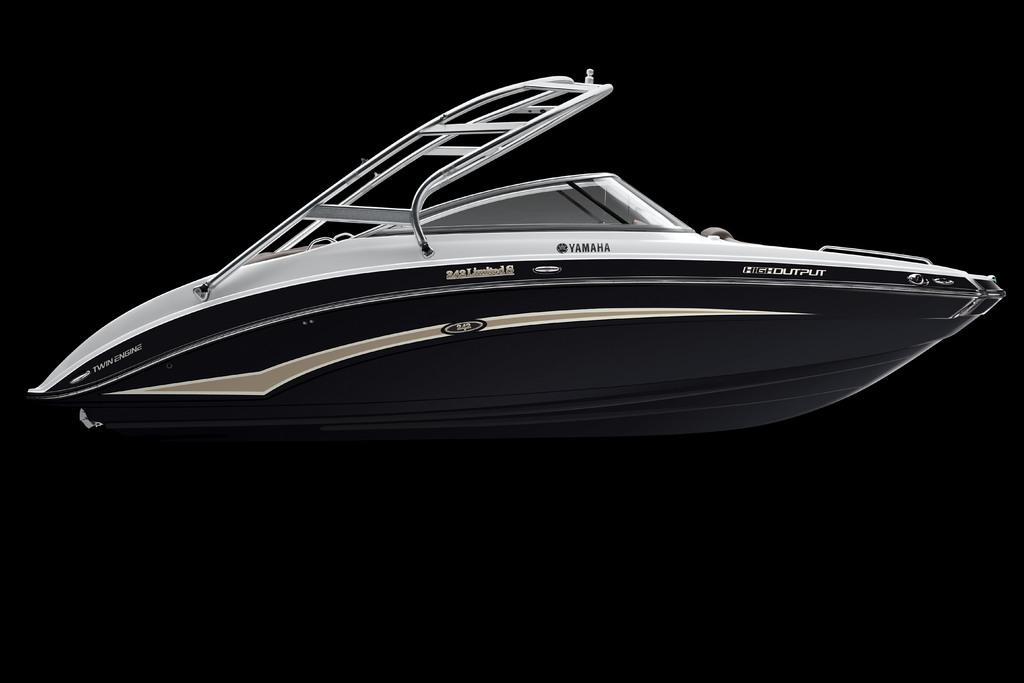<image>
Create a compact narrative representing the image presented. A Yamaha speedboat sits against a dark black background 